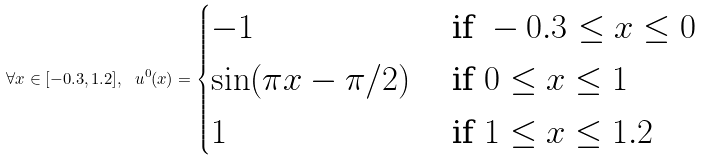Convert formula to latex. <formula><loc_0><loc_0><loc_500><loc_500>\forall x \in [ - 0 . 3 , 1 . 2 ] , \ u ^ { 0 } ( x ) = \begin{cases} - 1 & \text { if } - 0 . 3 \leq x \leq 0 \\ \sin ( \pi x - \pi / 2 ) & \text { if } 0 \leq x \leq 1 \\ 1 & \text { if } 1 \leq x \leq 1 . 2 \\ \end{cases}</formula> 